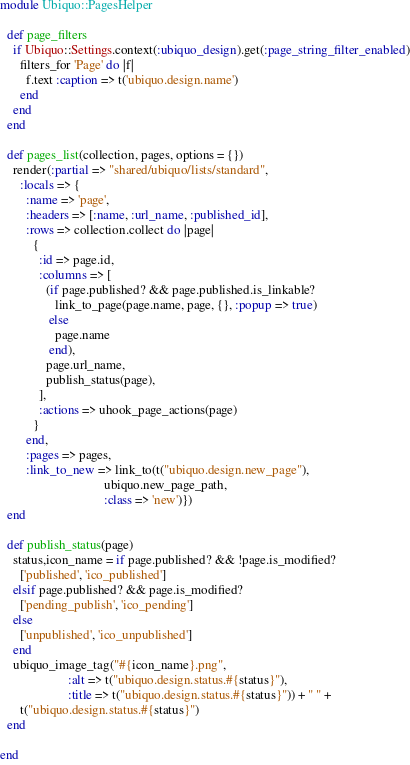Convert code to text. <code><loc_0><loc_0><loc_500><loc_500><_Ruby_>module Ubiquo::PagesHelper

  def page_filters
    if Ubiquo::Settings.context(:ubiquo_design).get(:page_string_filter_enabled)
      filters_for 'Page' do |f|
        f.text :caption => t('ubiquo.design.name')
      end
    end
  end

  def pages_list(collection, pages, options = {})
    render(:partial => "shared/ubiquo/lists/standard",
      :locals => {
        :name => 'page',
        :headers => [:name, :url_name, :published_id],
        :rows => collection.collect do |page|
          {
            :id => page.id,
            :columns => [
              (if page.published? && page.published.is_linkable?
                 link_to_page(page.name, page, {}, :popup => true)
               else
                 page.name
               end),
              page.url_name,
              publish_status(page),
            ],
            :actions => uhook_page_actions(page)
          }
        end,
        :pages => pages,
        :link_to_new => link_to(t("ubiquo.design.new_page"),
                                ubiquo.new_page_path,
                                :class => 'new')})
  end

  def publish_status(page)
    status,icon_name = if page.published? && !page.is_modified?
      ['published', 'ico_published']
    elsif page.published? && page.is_modified?
      ['pending_publish', 'ico_pending']
    else
      ['unpublished', 'ico_unpublished']
    end
    ubiquo_image_tag("#{icon_name}.png",
                     :alt => t("ubiquo.design.status.#{status}"),
                     :title => t("ubiquo.design.status.#{status}")) + " " +
      t("ubiquo.design.status.#{status}")
  end

end
</code> 